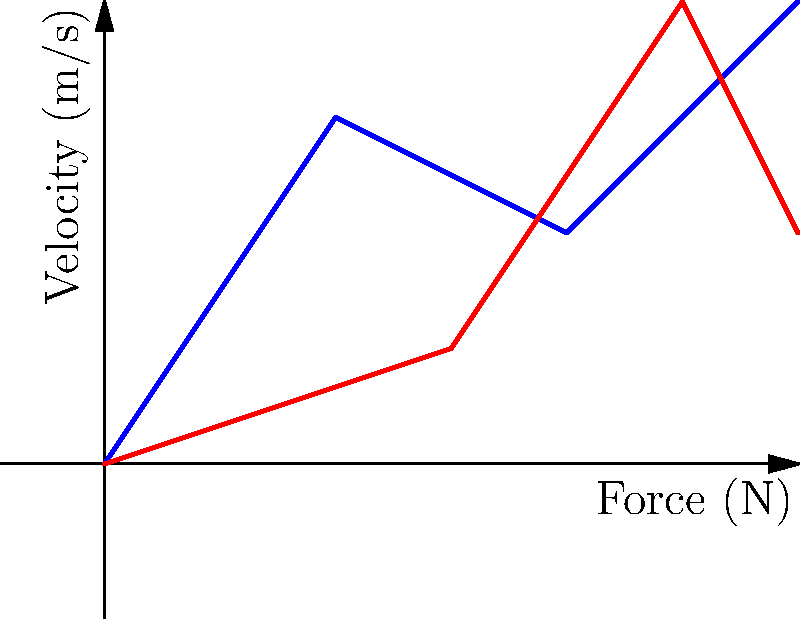In the graph above, the blue line represents Kate Bush's dance movements, while the red line represents the Demogorgon's movements. Both lines show the relationship between force and velocity. If the area under each curve represents the work done, which entity (Kate Bush or the Demogorgon) performs more work over the given range? To determine which entity performs more work, we need to compare the areas under their respective curves. The work done is equal to the area under the force-velocity curve. Let's break this down step-by-step:

1. Recall the work-energy theorem: $W = \int F \cdot dx = \int F \cdot v \cdot dt$

2. In the force-velocity graph, the area under the curve represents work done.

3. For Kate Bush (blue line):
   - The curve is smoother and generally higher in the velocity axis.
   - It encloses a larger area with the x-axis.

4. For the Demogorgon (red line):
   - The curve is more erratic with sharp changes.
   - It encloses a smaller area with the x-axis.

5. Visually estimating the areas:
   - Kate Bush's curve appears to enclose approximately 1.5 times the area of the Demogorgon's curve.

6. Therefore, based on this graph, Kate Bush's dance movements involve more work done over the given range of force and velocity.

This aligns with the persona's understanding of Kate Bush's intense and expressive dance performances in music videos like "Wuthering Heights," which would indeed require significant energy expenditure compared to the more primal, less choreographed movements of the Demogorgon.
Answer: Kate Bush performs more work. 